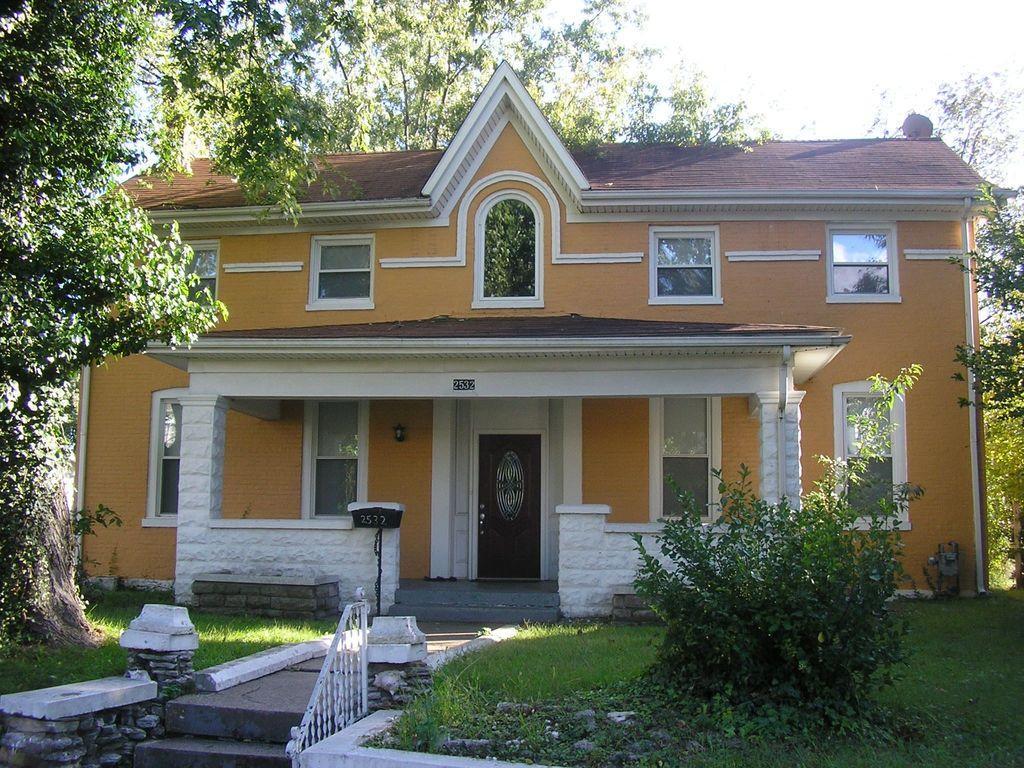Please provide a concise description of this image. In this image we can see a building, few trees, grass, railing, stairs and the sky in the background. 